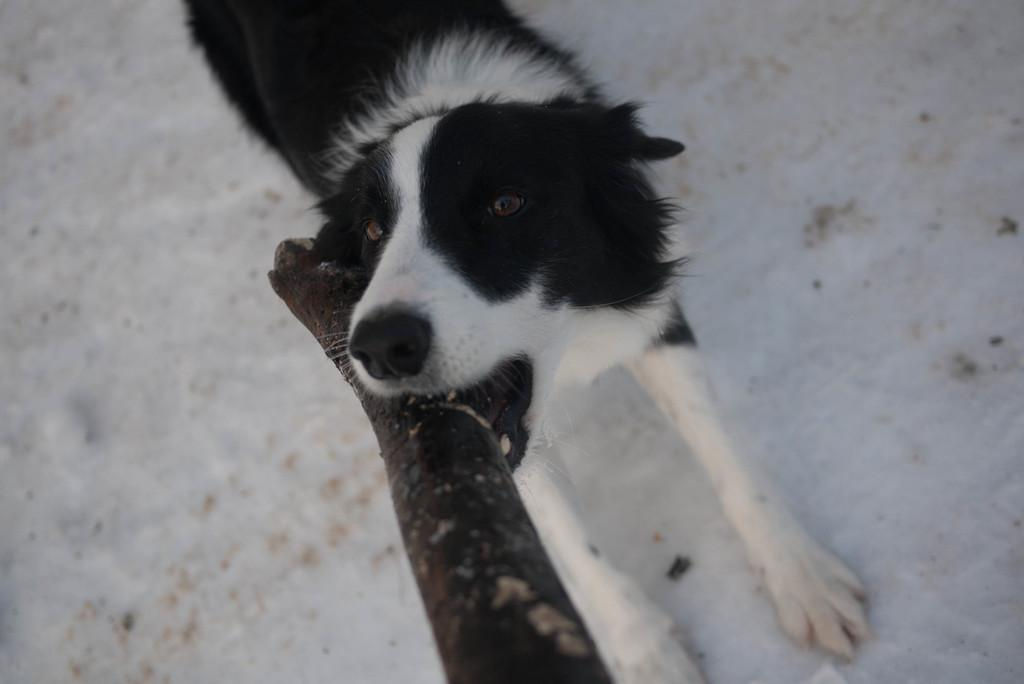What type of animal is in the image? There is a dog in the image. What colors can be seen on the dog? The dog is white and black in color. What is the dog holding in its mouth? The dog is holding a wooden stick in its mouth. What is the color of the floor the dog is standing on? The dog is standing on a white floor. What type of lace design can be seen on the dog's collar in the image? There is no collar visible on the dog in the image, and therefore no lace design can be observed. 